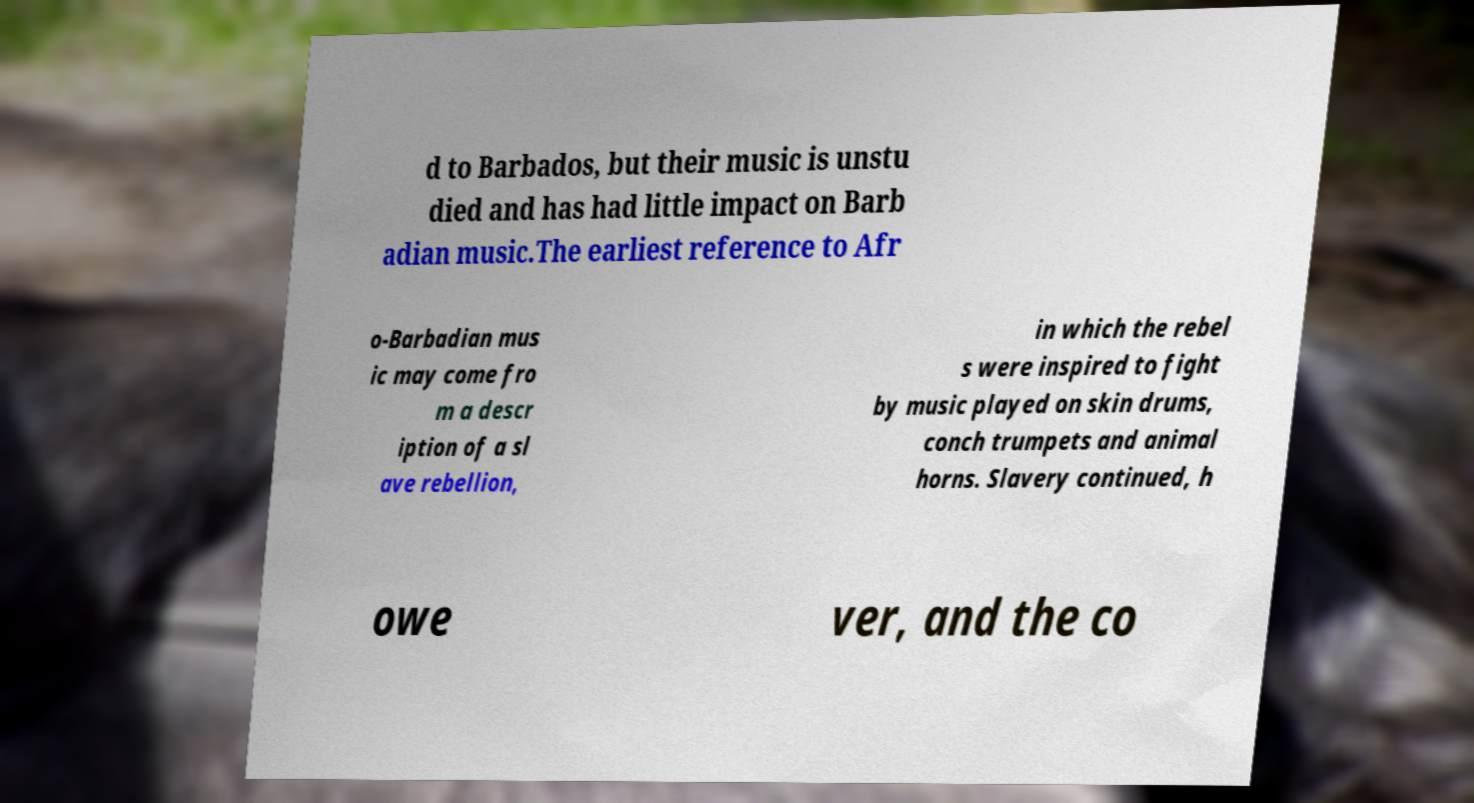Please read and relay the text visible in this image. What does it say? d to Barbados, but their music is unstu died and has had little impact on Barb adian music.The earliest reference to Afr o-Barbadian mus ic may come fro m a descr iption of a sl ave rebellion, in which the rebel s were inspired to fight by music played on skin drums, conch trumpets and animal horns. Slavery continued, h owe ver, and the co 